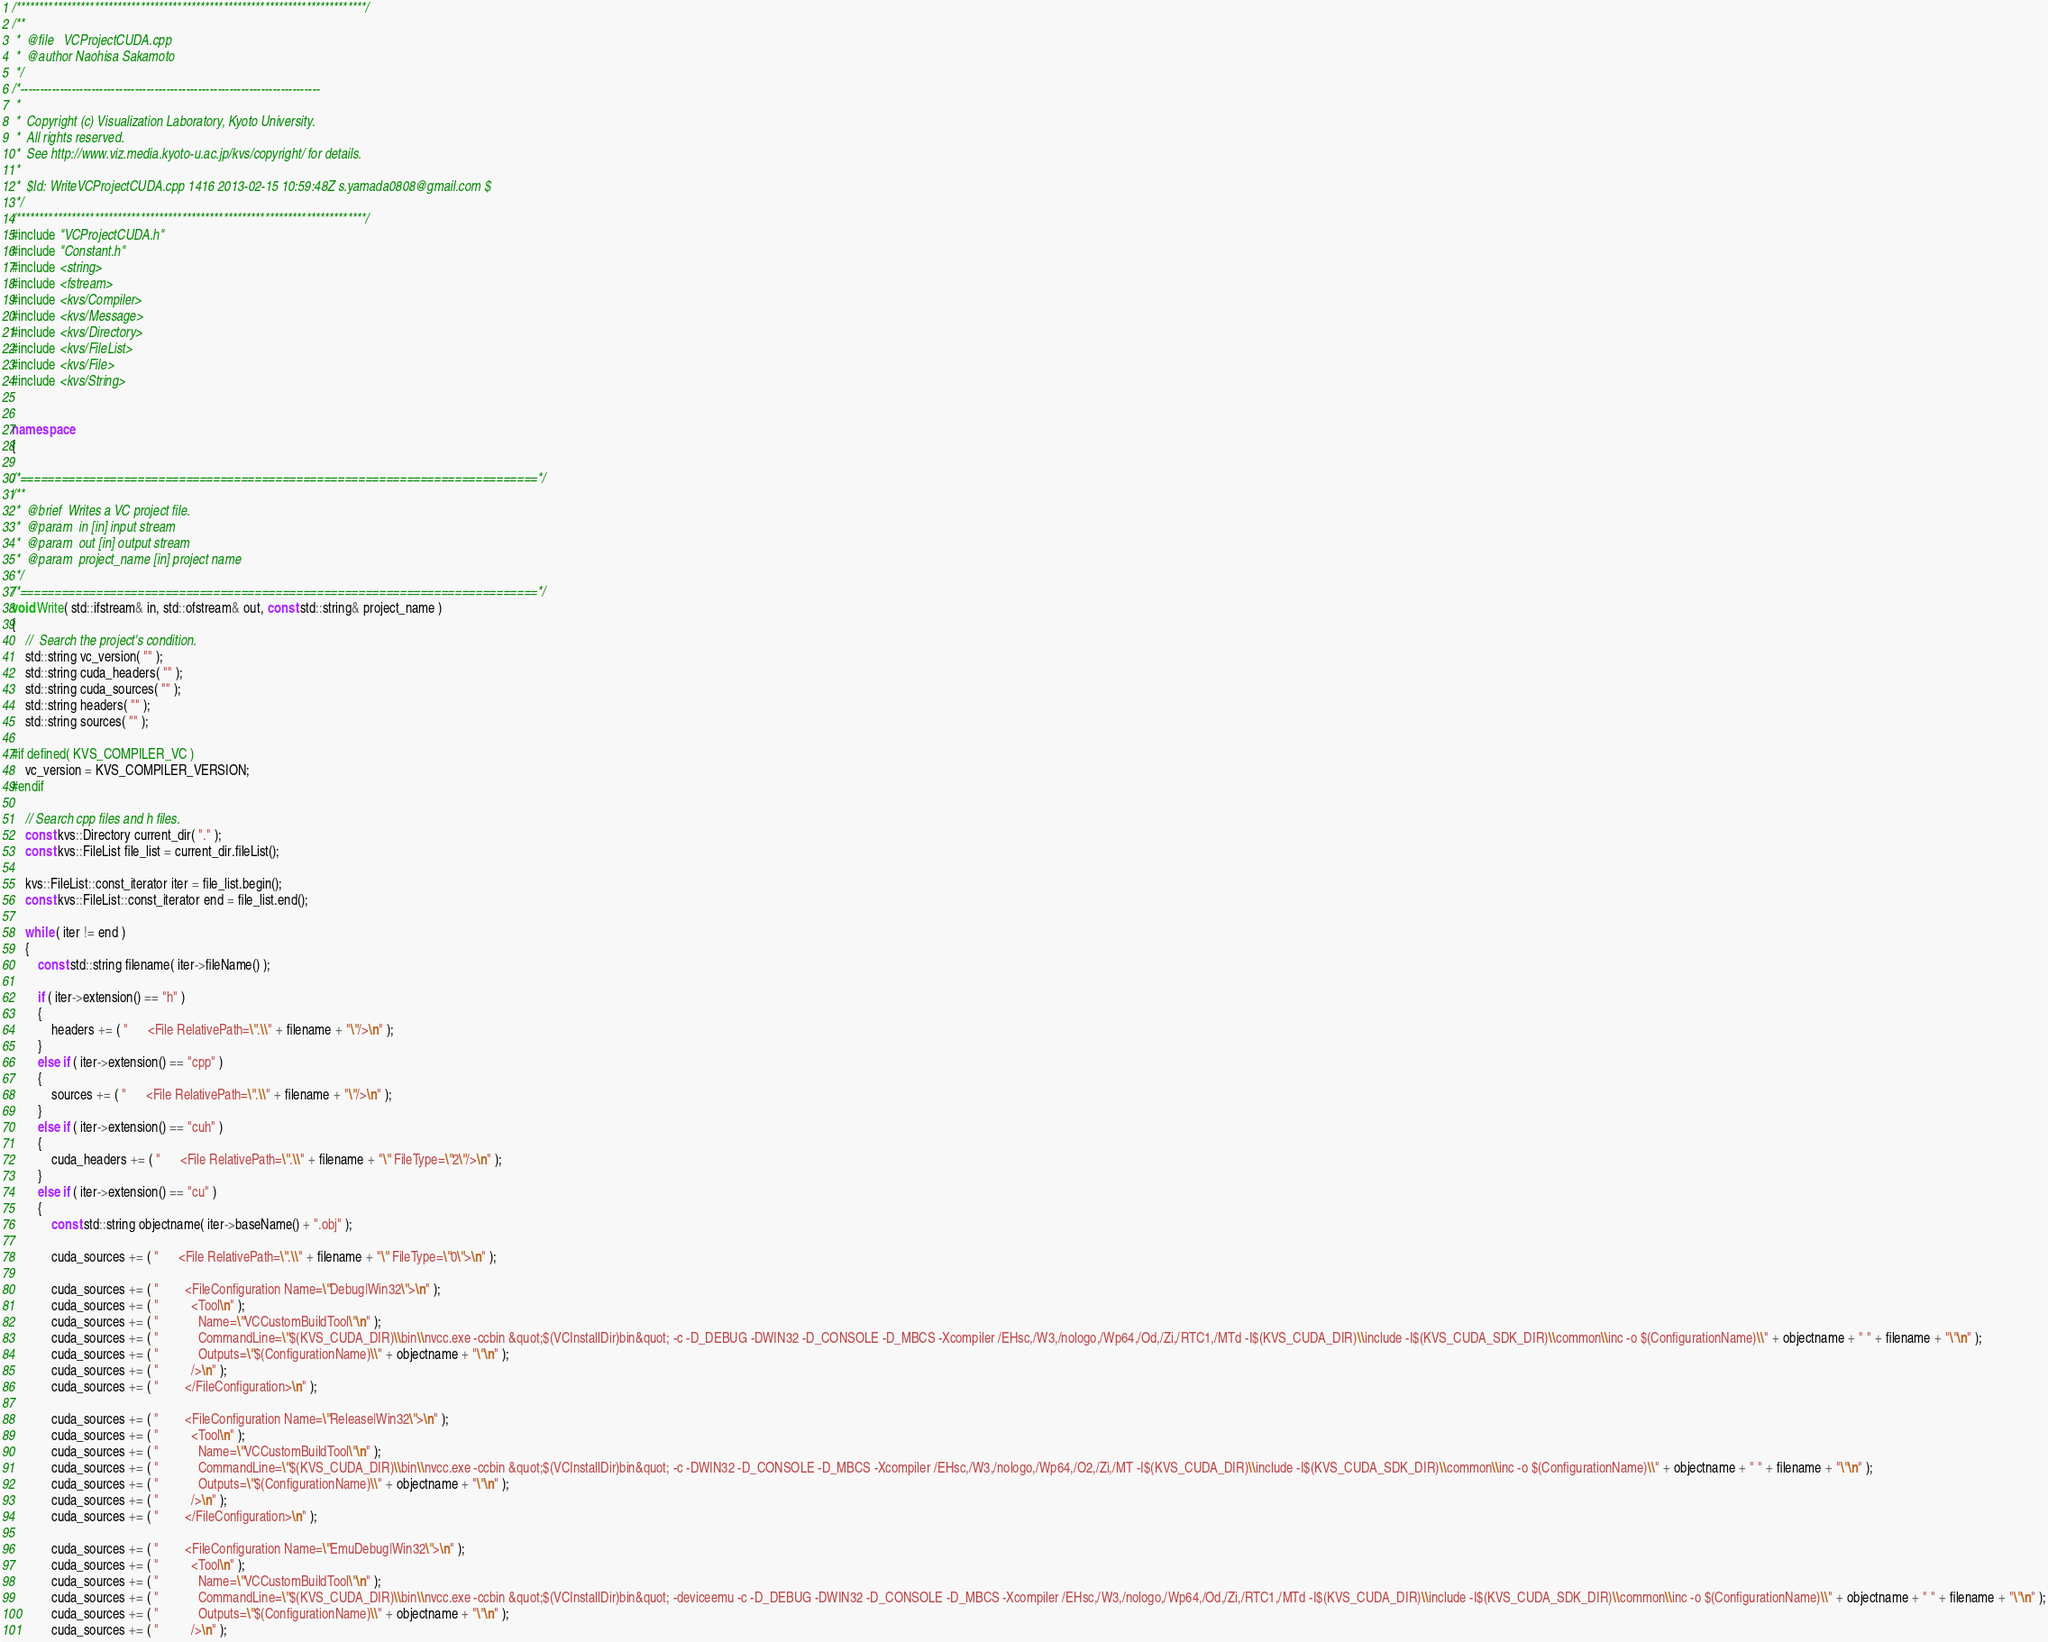Convert code to text. <code><loc_0><loc_0><loc_500><loc_500><_C++_>/****************************************************************************/
/**
 *  @file   VCProjectCUDA.cpp
 *  @author Naohisa Sakamoto
 */
/*----------------------------------------------------------------------------
 *
 *  Copyright (c) Visualization Laboratory, Kyoto University.
 *  All rights reserved.
 *  See http://www.viz.media.kyoto-u.ac.jp/kvs/copyright/ for details.
 *
 *  $Id: WriteVCProjectCUDA.cpp 1416 2013-02-15 10:59:48Z s.yamada0808@gmail.com $
 */
/****************************************************************************/
#include "VCProjectCUDA.h"
#include "Constant.h"
#include <string>
#include <fstream>
#include <kvs/Compiler>
#include <kvs/Message>
#include <kvs/Directory>
#include <kvs/FileList>
#include <kvs/File>
#include <kvs/String>


namespace
{

/*===========================================================================*/
/**
 *  @brief  Writes a VC project file.
 *  @param  in [in] input stream
 *  @param  out [in] output stream
 *  @param  project_name [in] project name
 */
/*===========================================================================*/
void Write( std::ifstream& in, std::ofstream& out, const std::string& project_name )
{
    //  Search the project's condition.
    std::string vc_version( "" );
    std::string cuda_headers( "" );
    std::string cuda_sources( "" );
    std::string headers( "" );
    std::string sources( "" );

#if defined( KVS_COMPILER_VC )
    vc_version = KVS_COMPILER_VERSION;
#endif

    // Search cpp files and h files.
    const kvs::Directory current_dir( "." );
    const kvs::FileList file_list = current_dir.fileList();

    kvs::FileList::const_iterator iter = file_list.begin();
    const kvs::FileList::const_iterator end = file_list.end();

    while ( iter != end )
    {
        const std::string filename( iter->fileName() );

        if ( iter->extension() == "h" )
        {
            headers += ( "      <File RelativePath=\".\\" + filename + "\"/>\n" );
        }
        else if ( iter->extension() == "cpp" )
        {
            sources += ( "      <File RelativePath=\".\\" + filename + "\"/>\n" );
        }
        else if ( iter->extension() == "cuh" )
        {
            cuda_headers += ( "      <File RelativePath=\".\\" + filename + "\" FileType=\"2\"/>\n" );
        }
        else if ( iter->extension() == "cu" )
        {
            const std::string objectname( iter->baseName() + ".obj" );

            cuda_sources += ( "      <File RelativePath=\".\\" + filename + "\" FileType=\"0\">\n" );

            cuda_sources += ( "        <FileConfiguration Name=\"Debug|Win32\">\n" );
            cuda_sources += ( "          <Tool\n" );
            cuda_sources += ( "            Name=\"VCCustomBuildTool\"\n" );
            cuda_sources += ( "            CommandLine=\"$(KVS_CUDA_DIR)\\bin\\nvcc.exe -ccbin &quot;$(VCInstallDir)bin&quot; -c -D_DEBUG -DWIN32 -D_CONSOLE -D_MBCS -Xcompiler /EHsc,/W3,/nologo,/Wp64,/Od,/Zi,/RTC1,/MTd -I$(KVS_CUDA_DIR)\\include -I$(KVS_CUDA_SDK_DIR)\\common\\inc -o $(ConfigurationName)\\" + objectname + " " + filename + "\"\n" );
            cuda_sources += ( "            Outputs=\"$(ConfigurationName)\\" + objectname + "\"\n" );
            cuda_sources += ( "          />\n" );
            cuda_sources += ( "        </FileConfiguration>\n" );

            cuda_sources += ( "        <FileConfiguration Name=\"Release|Win32\">\n" );
            cuda_sources += ( "          <Tool\n" );
            cuda_sources += ( "            Name=\"VCCustomBuildTool\"\n" );
            cuda_sources += ( "            CommandLine=\"$(KVS_CUDA_DIR)\\bin\\nvcc.exe -ccbin &quot;$(VCInstallDir)bin&quot; -c -DWIN32 -D_CONSOLE -D_MBCS -Xcompiler /EHsc,/W3,/nologo,/Wp64,/O2,/Zi,/MT -I$(KVS_CUDA_DIR)\\include -I$(KVS_CUDA_SDK_DIR)\\common\\inc -o $(ConfigurationName)\\" + objectname + " " + filename + "\"\n" );
            cuda_sources += ( "            Outputs=\"$(ConfigurationName)\\" + objectname + "\"\n" );
            cuda_sources += ( "          />\n" );
            cuda_sources += ( "        </FileConfiguration>\n" );

            cuda_sources += ( "        <FileConfiguration Name=\"EmuDebug|Win32\">\n" );
            cuda_sources += ( "          <Tool\n" );
            cuda_sources += ( "            Name=\"VCCustomBuildTool\"\n" );
            cuda_sources += ( "            CommandLine=\"$(KVS_CUDA_DIR)\\bin\\nvcc.exe -ccbin &quot;$(VCInstallDir)bin&quot; -deviceemu -c -D_DEBUG -DWIN32 -D_CONSOLE -D_MBCS -Xcompiler /EHsc,/W3,/nologo,/Wp64,/Od,/Zi,/RTC1,/MTd -I$(KVS_CUDA_DIR)\\include -I$(KVS_CUDA_SDK_DIR)\\common\\inc -o $(ConfigurationName)\\" + objectname + " " + filename + "\"\n" );
            cuda_sources += ( "            Outputs=\"$(ConfigurationName)\\" + objectname + "\"\n" );
            cuda_sources += ( "          />\n" );</code> 